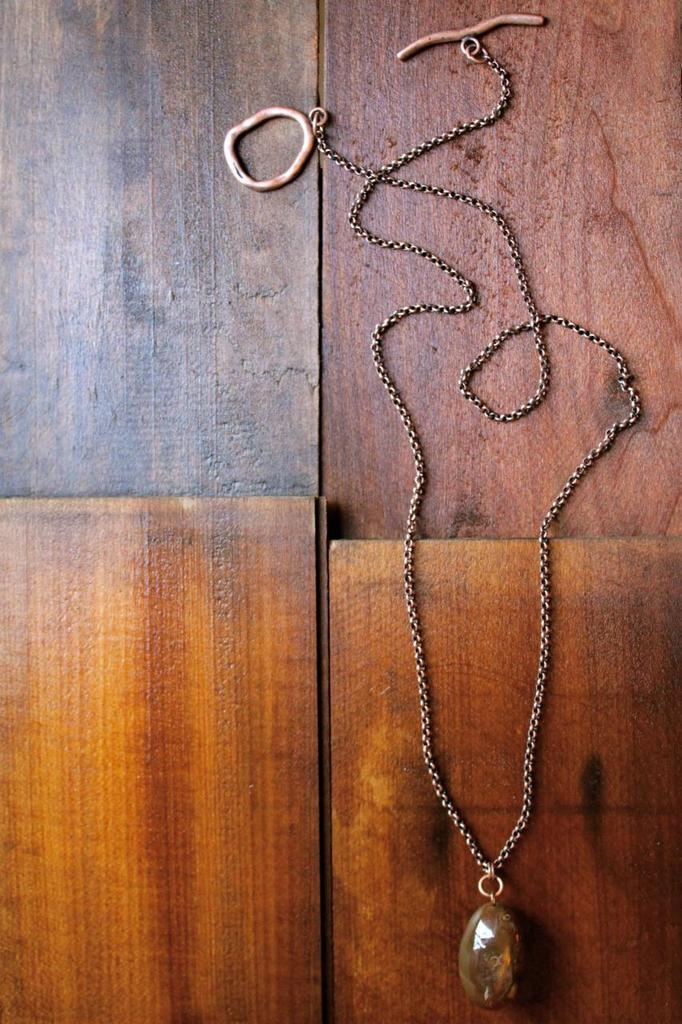What is the main object in the image? There is a chain with a pendant in the image. Where is the chain and pendant located? The chain and pendant are on a wooden platform. How does the road expand in the image? There is no road present in the image; it features a chain with a pendant on a wooden platform. What is the level of interest in the image? The level of interest in the image cannot be determined from the image itself, as it depends on the viewer's personal preferences. 